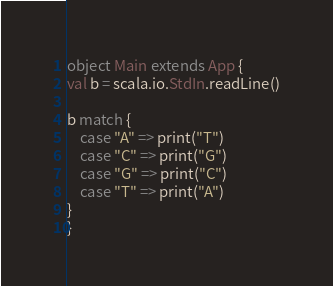Convert code to text. <code><loc_0><loc_0><loc_500><loc_500><_Scala_>object Main extends App {
val b = scala.io.StdIn.readLine()

b match {
    case "A" => print("T")
    case "C" => print("G")
    case "G" => print("C")
    case "T" => print("A")
}
}</code> 